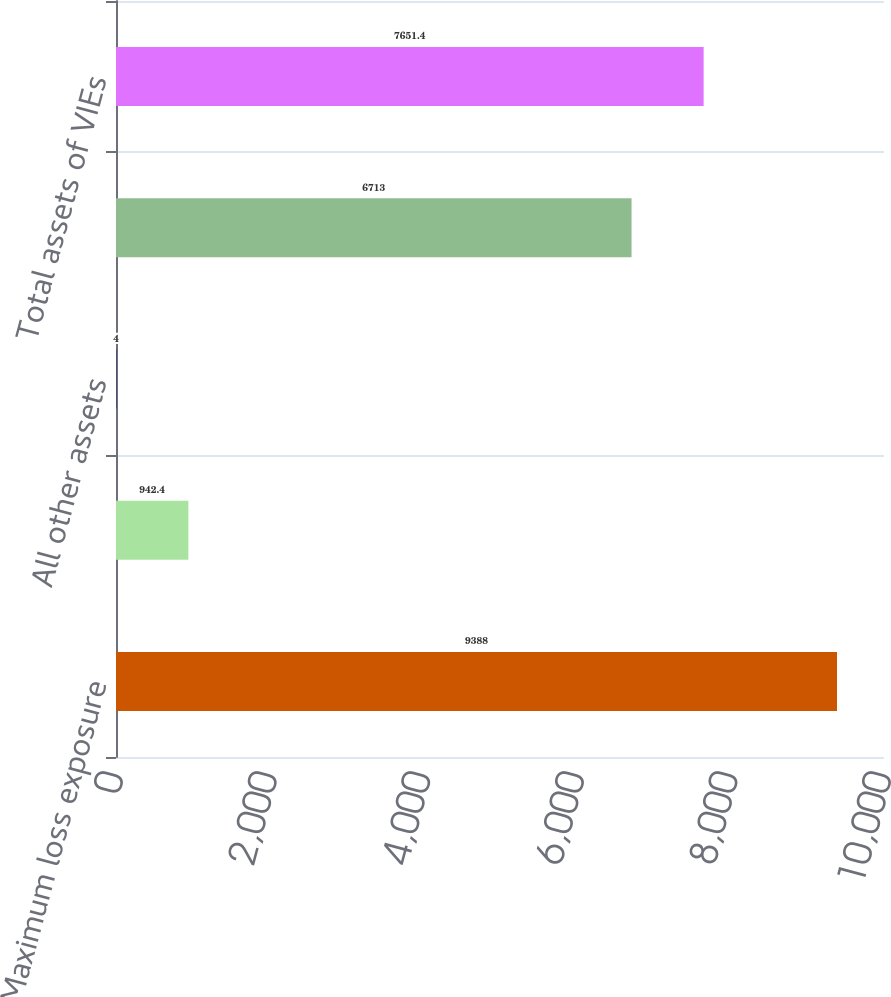Convert chart. <chart><loc_0><loc_0><loc_500><loc_500><bar_chart><fcel>Maximum loss exposure<fcel>Loans and leases<fcel>All other assets<fcel>Total<fcel>Total assets of VIEs<nl><fcel>9388<fcel>942.4<fcel>4<fcel>6713<fcel>7651.4<nl></chart> 